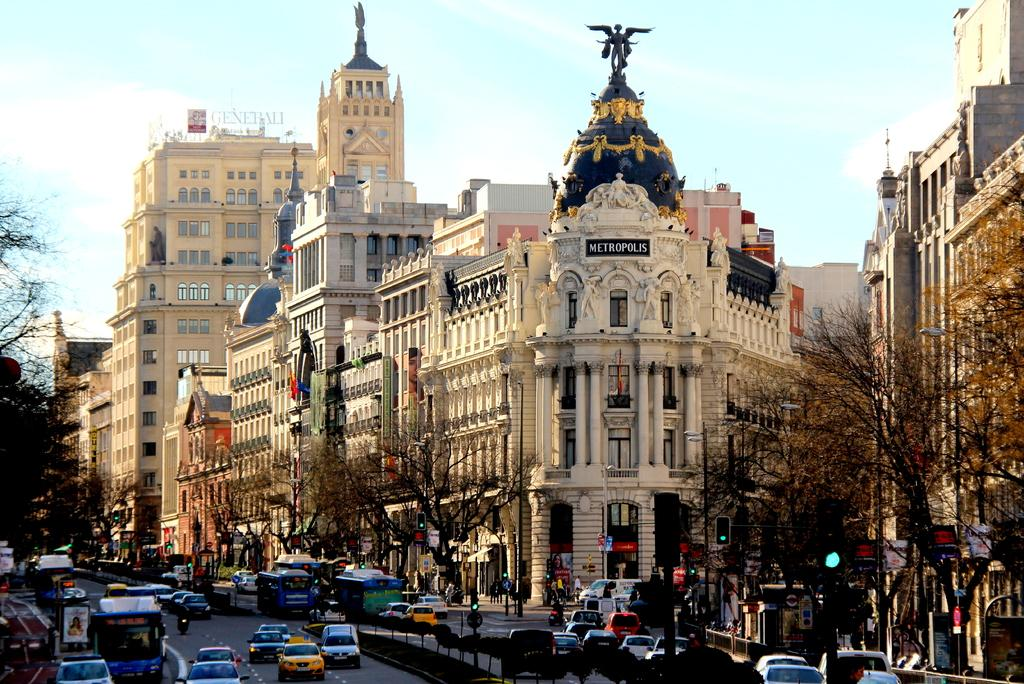What is happening on the road in the image? There are vehicles passing on the road in the image. What can be seen beside the road in the image? There are trees beside the road in the image. What helps regulate traffic in the image? There are traffic lights in the image. What provides information or directions in the image? There are sign boards in the image. What can be seen in the distance in the image? There are buildings in the background of the image. Can you see any waves crashing on the shore in the image? There are no waves or shore visible in the image; it features a road with vehicles, trees, traffic lights, sign boards, and buildings in the background. What scale is used to measure the height of the buildings in the image? There is no scale present in the image, and the heights of the buildings cannot be determined from the image alone. 